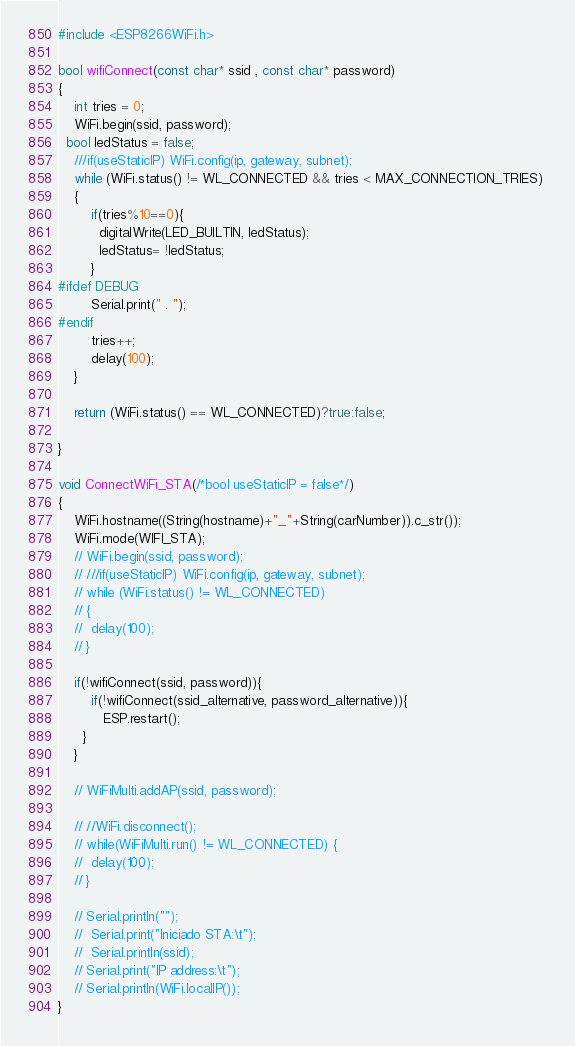<code> <loc_0><loc_0><loc_500><loc_500><_C++_>#include <ESP8266WiFi.h>

bool wifiConnect(const char* ssid , const char* password)
{
	int tries = 0;
	WiFi.begin(ssid, password);
  bool ledStatus = false;	
	///if(useStaticIP) WiFi.config(ip, gateway, subnet);
	while (WiFi.status() != WL_CONNECTED && tries < MAX_CONNECTION_TRIES) 
	{ 
		if(tries%10==0){
		  digitalWrite(LED_BUILTIN, ledStatus);
		  ledStatus= !ledStatus;
		}
#ifdef DEBUG
		Serial.print(" . ");
#endif
		tries++;
		delay(100);
	}

	return (WiFi.status() == WL_CONNECTED)?true:false;

}

void ConnectWiFi_STA(/*bool useStaticIP = false*/)
{	
	WiFi.hostname((String(hostname)+"_"+String(carNumber)).c_str());
	WiFi.mode(WIFI_STA);
	// WiFi.begin(ssid, password);
	// ///if(useStaticIP) WiFi.config(ip, gateway, subnet);
	// while (WiFi.status() != WL_CONNECTED) 
	// { 
	// 	delay(100);  
	// }

	if(!wifiConnect(ssid, password)){		
		if(!wifiConnect(ssid_alternative, password_alternative)){
		   ESP.restart();
 	  }
	}

	// WiFiMulti.addAP(ssid, password);

	// //WiFi.disconnect();
	// while(WiFiMulti.run() != WL_CONNECTED) {
	// 	delay(100);
	// }

	// Serial.println("");
	//  Serial.print("Iniciado STA:\t");
	//  Serial.println(ssid);
	// Serial.print("IP address:\t");
	// Serial.println(WiFi.localIP());
}</code> 